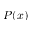<formula> <loc_0><loc_0><loc_500><loc_500>P ( x )</formula> 